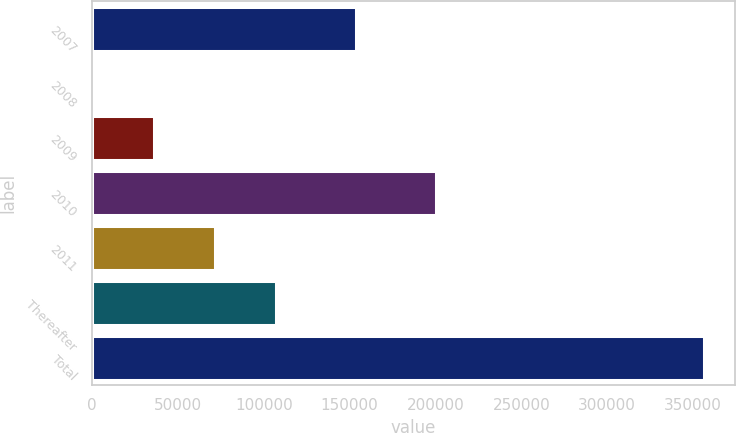Convert chart to OTSL. <chart><loc_0><loc_0><loc_500><loc_500><bar_chart><fcel>2007<fcel>2008<fcel>2009<fcel>2010<fcel>2011<fcel>Thereafter<fcel>Total<nl><fcel>153682<fcel>245<fcel>35883.7<fcel>200353<fcel>71522.4<fcel>107161<fcel>356632<nl></chart> 